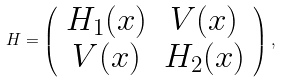Convert formula to latex. <formula><loc_0><loc_0><loc_500><loc_500>H = \left ( \begin{array} { c c } H _ { 1 } ( x ) & V ( x ) \\ V ( x ) & H _ { 2 } ( x ) \end{array} \right ) ,</formula> 